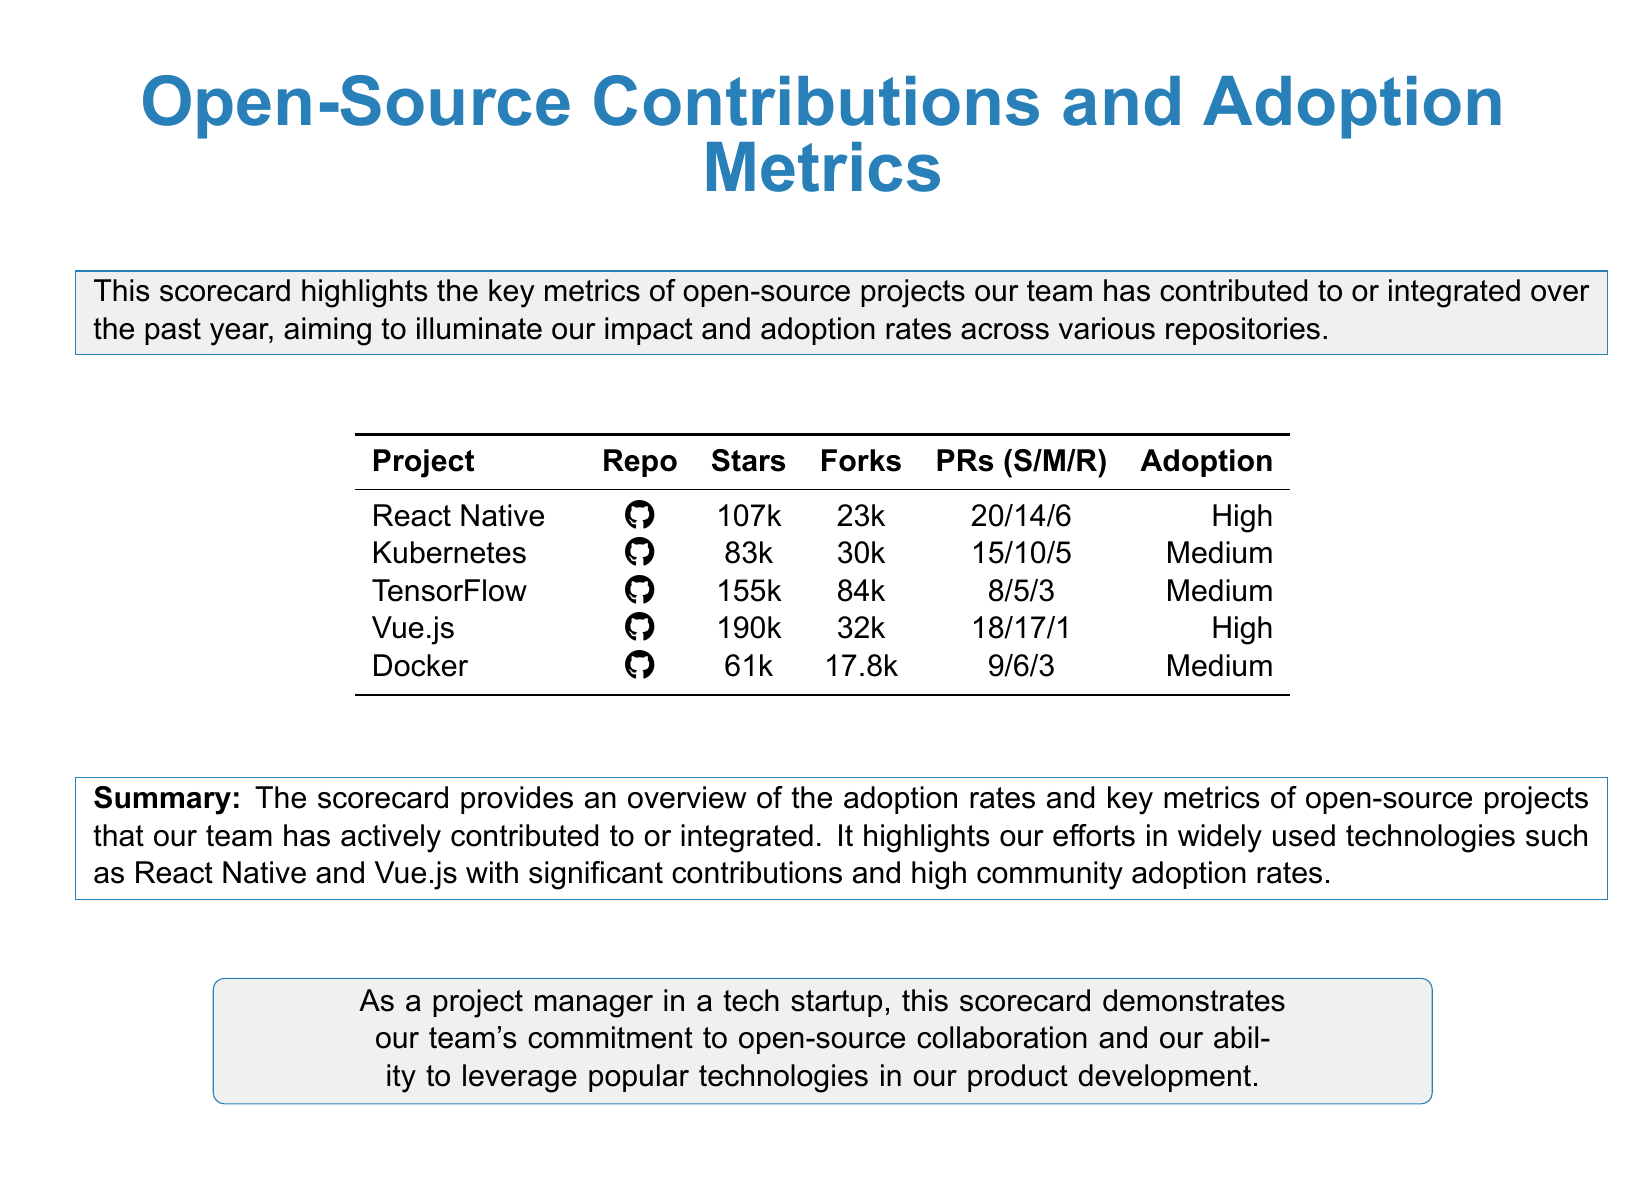What is the project with the highest number of stars? The project with the highest number of stars in the document is identified based on the stars column in the table.
Answer: TensorFlow How many forks does Vue.js have? The number of forks for Vue.js is directly taken from the forks column in the table.
Answer: 32k What percentage of the PRs for React Native are successful? The percentage is calculated by dividing successful PRs by total PRs, represented in the format S/M/R.
Answer: 100 Which project has a medium adoption rate? The projects with medium adoption rates are identified from the adoption column in the table.
Answer: Kubernetes How many pull requests has Kubernetes received? The total number of pull requests for Kubernetes can be summed up by adding successful, merged, and rejected PRs.
Answer: 30 What is the common theme of the projects listed? The projects in the document focus on a specific area of technology and community engagement.
Answer: Open-source technology What is the color theme used in the scorecard? The primary colors used in the scorecard are evident in the document's design.
Answer: Tech blue How many projects have a high adoption rate? The count is based on the adoption rates given for each project listed.
Answer: 2 What type of document is this scorecard classified as? The format and content of this document categorize it in a specific manner related to tracking metrics.
Answer: Scorecard 